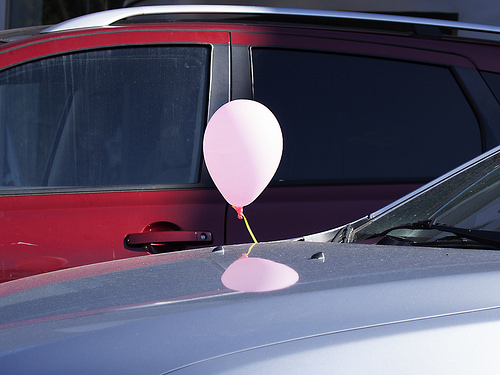<image>
Can you confirm if the balloon is next to the car? Yes. The balloon is positioned adjacent to the car, located nearby in the same general area. 